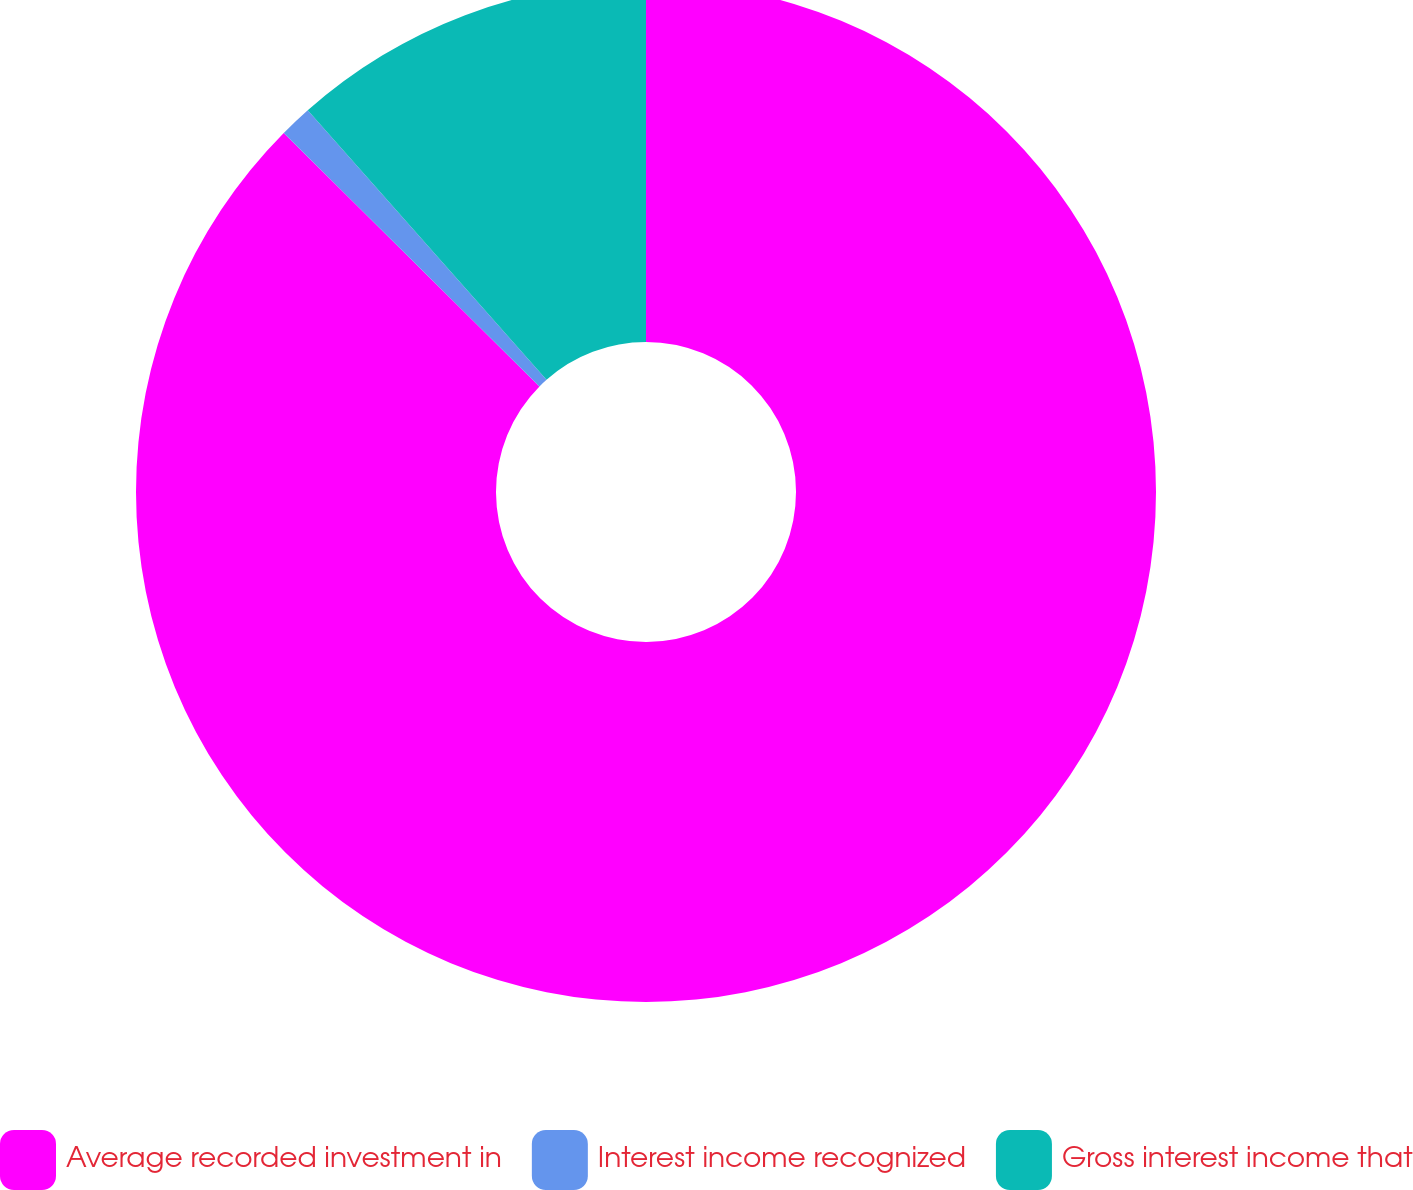Convert chart to OTSL. <chart><loc_0><loc_0><loc_500><loc_500><pie_chart><fcel>Average recorded investment in<fcel>Interest income recognized<fcel>Gross interest income that<nl><fcel>87.42%<fcel>1.03%<fcel>11.54%<nl></chart> 